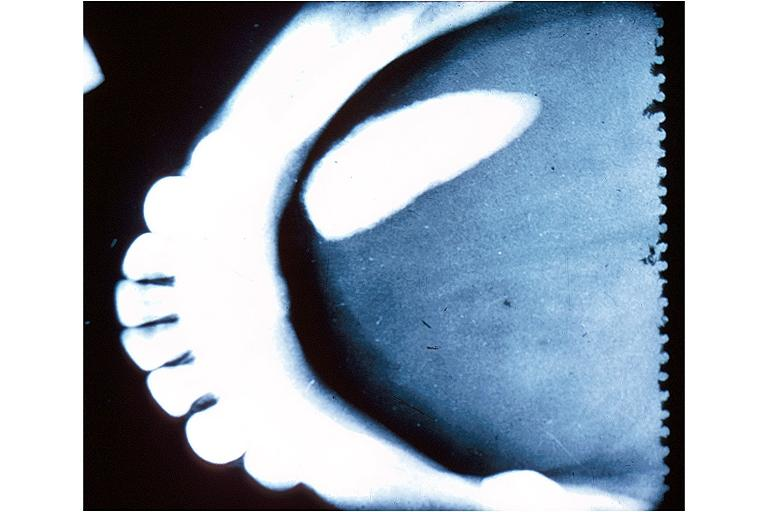s oral present?
Answer the question using a single word or phrase. Yes 